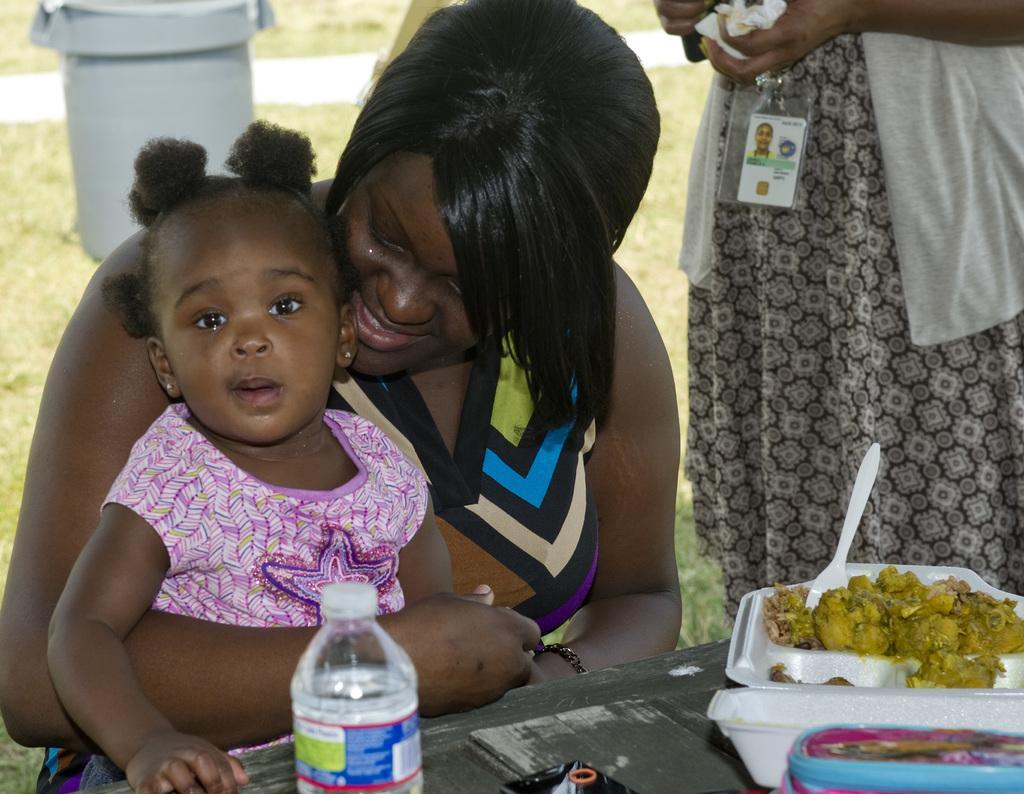In one or two sentences, can you explain what this image depicts? This picture shows a woman standing and a woman seated holding a girl in her hand and we see some food and a water bottle on the table and we see a dustbin on her back 